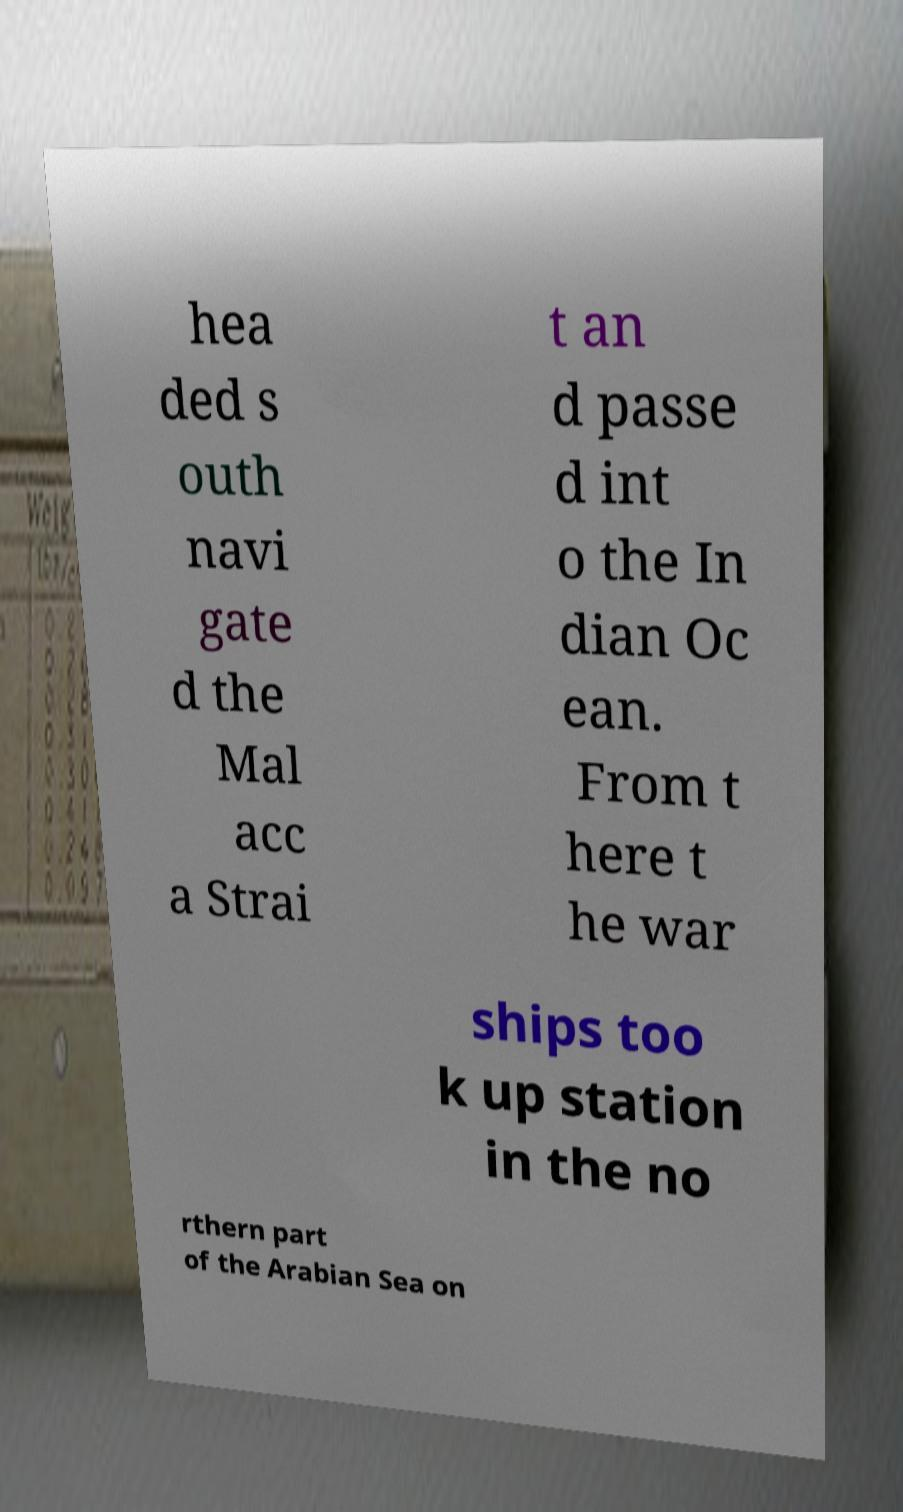Can you accurately transcribe the text from the provided image for me? hea ded s outh navi gate d the Mal acc a Strai t an d passe d int o the In dian Oc ean. From t here t he war ships too k up station in the no rthern part of the Arabian Sea on 